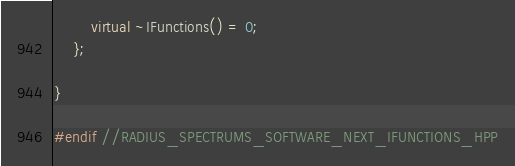Convert code to text. <code><loc_0><loc_0><loc_500><loc_500><_C++_>        virtual ~IFunctions() = 0;
    };

}

#endif //RADIUS_SPECTRUMS_SOFTWARE_NEXT_IFUNCTIONS_HPP
</code> 